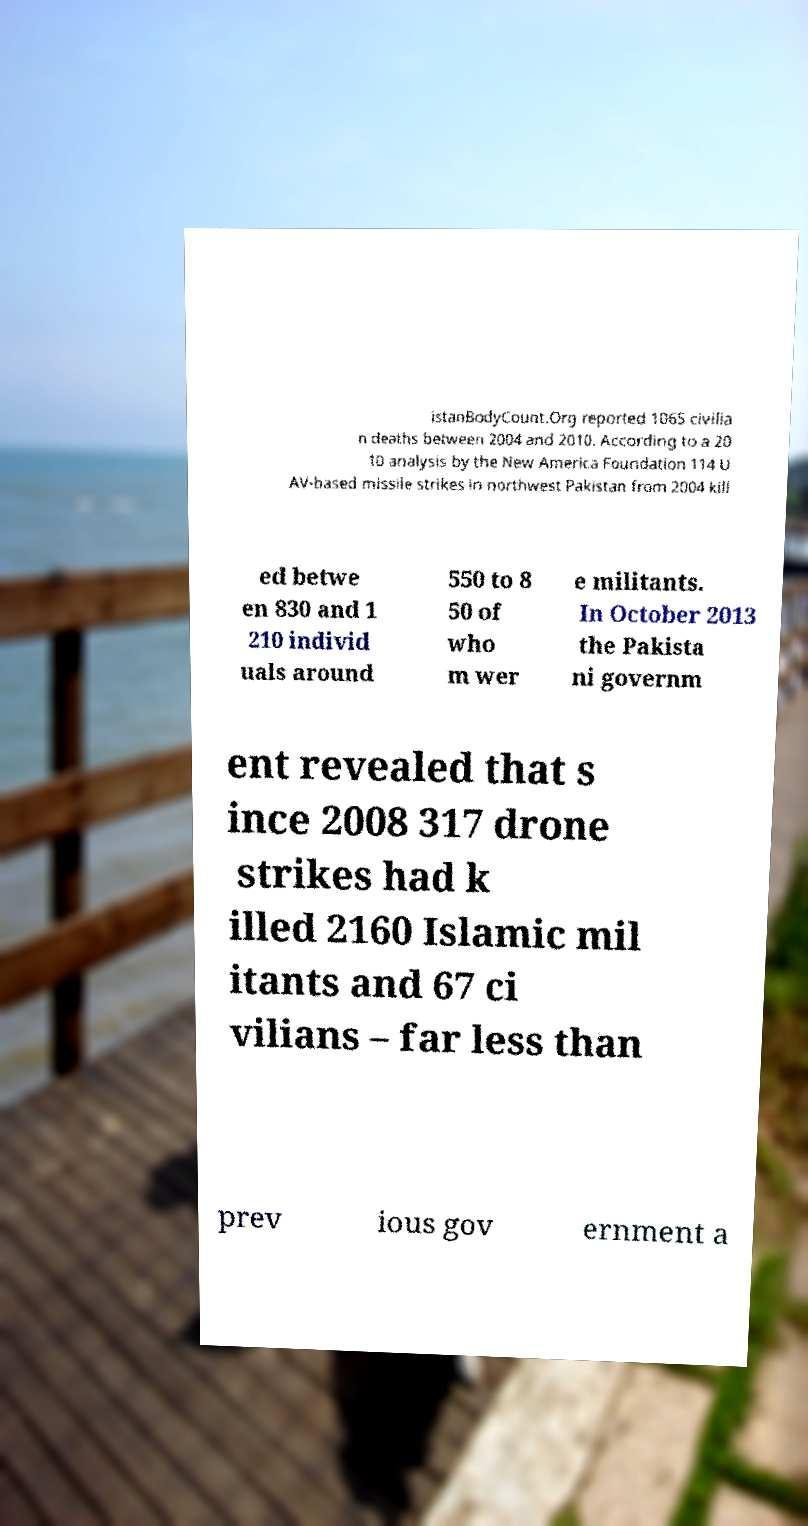Can you accurately transcribe the text from the provided image for me? istanBodyCount.Org reported 1065 civilia n deaths between 2004 and 2010. According to a 20 10 analysis by the New America Foundation 114 U AV-based missile strikes in northwest Pakistan from 2004 kill ed betwe en 830 and 1 210 individ uals around 550 to 8 50 of who m wer e militants. In October 2013 the Pakista ni governm ent revealed that s ince 2008 317 drone strikes had k illed 2160 Islamic mil itants and 67 ci vilians – far less than prev ious gov ernment a 